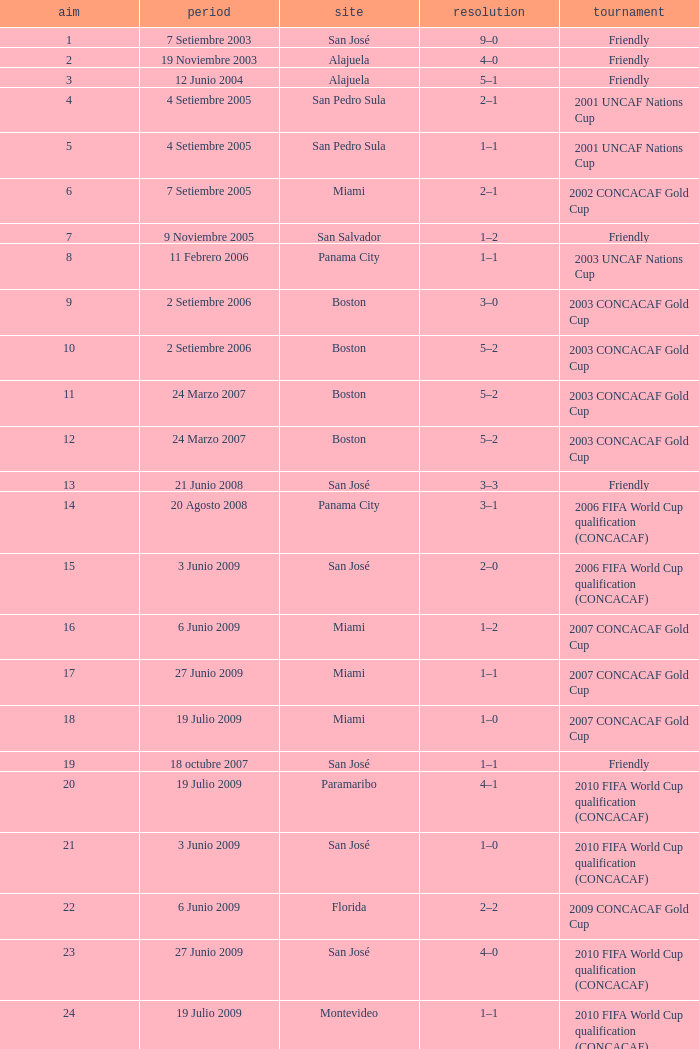At the venue of panama city, on 11 Febrero 2006, how many goals were scored? 1.0. 